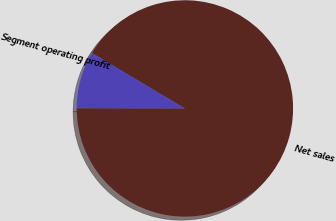<chart> <loc_0><loc_0><loc_500><loc_500><pie_chart><fcel>Net sales<fcel>Segment operating profit<nl><fcel>91.48%<fcel>8.52%<nl></chart> 